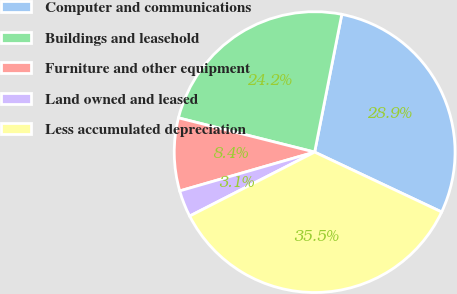Convert chart to OTSL. <chart><loc_0><loc_0><loc_500><loc_500><pie_chart><fcel>Computer and communications<fcel>Buildings and leasehold<fcel>Furniture and other equipment<fcel>Land owned and leased<fcel>Less accumulated depreciation<nl><fcel>28.92%<fcel>24.18%<fcel>8.38%<fcel>3.07%<fcel>35.46%<nl></chart> 